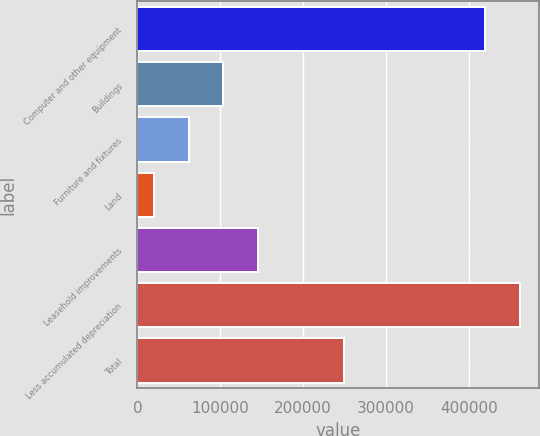Convert chart to OTSL. <chart><loc_0><loc_0><loc_500><loc_500><bar_chart><fcel>Computer and other equipment<fcel>Buildings<fcel>Furniture and fixtures<fcel>Land<fcel>Leasehold improvements<fcel>Less accumulated depreciation<fcel>Total<nl><fcel>419951<fcel>103879<fcel>62146.6<fcel>20414<fcel>145612<fcel>461684<fcel>249098<nl></chart> 